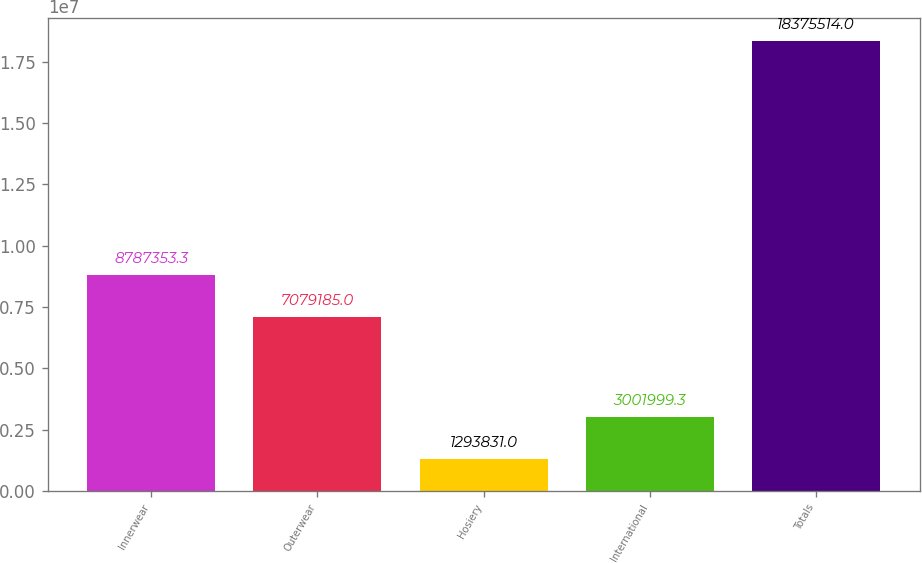Convert chart. <chart><loc_0><loc_0><loc_500><loc_500><bar_chart><fcel>Innerwear<fcel>Outerwear<fcel>Hosiery<fcel>International<fcel>Totals<nl><fcel>8.78735e+06<fcel>7.07918e+06<fcel>1.29383e+06<fcel>3.002e+06<fcel>1.83755e+07<nl></chart> 